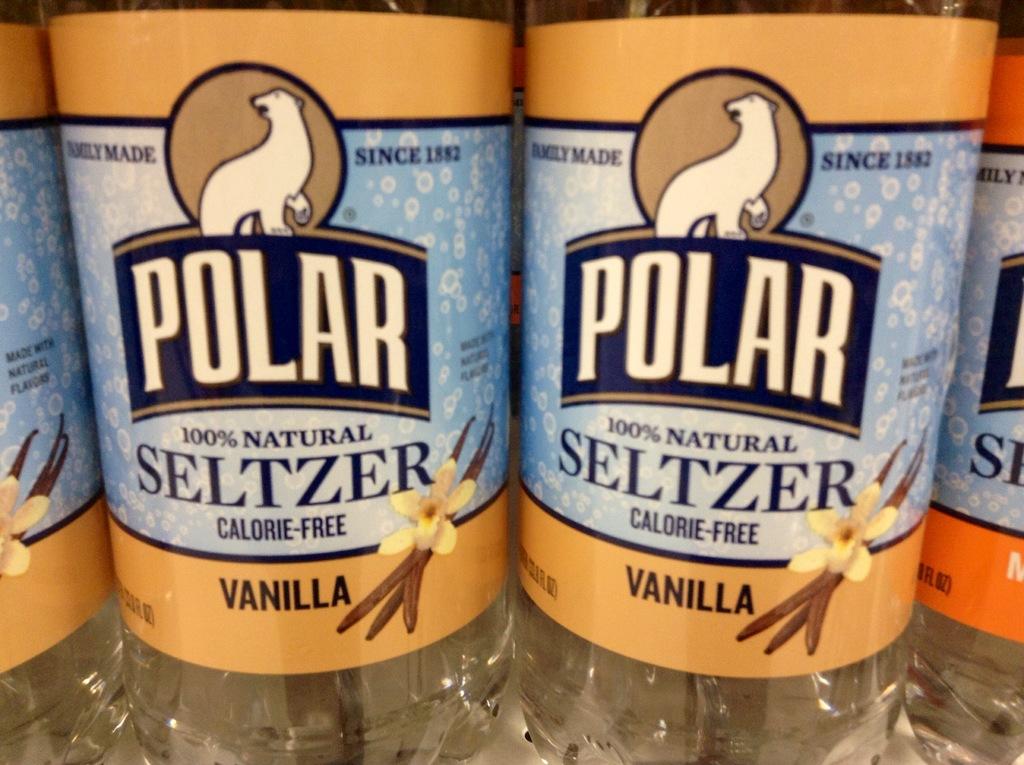What flavor is the seltzer?
Offer a very short reply. Vanilla. What brand is it?
Your answer should be compact. Polar. 